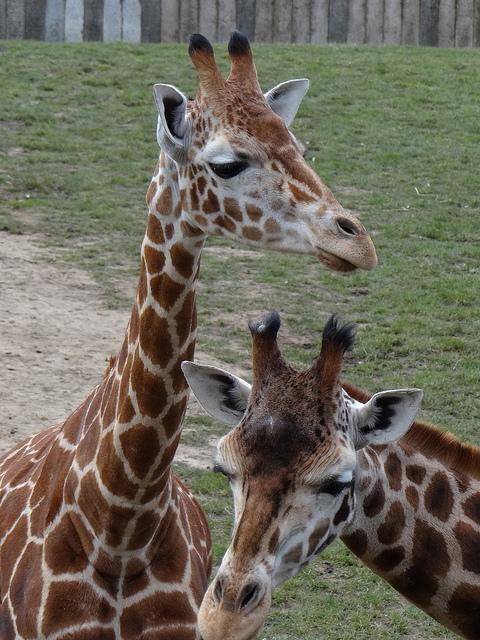Are the animals in a fence?
Answer briefly. Yes. Are giraffes the only animals in the photo?
Concise answer only. Yes. What is the giraffe on the left doing?
Quick response, please. Standing. How many giraffes are there?
Answer briefly. 2. Which eye is visible?
Concise answer only. Right. What is the giraffe doing?
Short answer required. Standing. How many animals are seen in the picture?
Write a very short answer. 2. How many giraffes are in the photo?
Quick response, please. 2. How many gazelles?
Quick response, please. 0. 